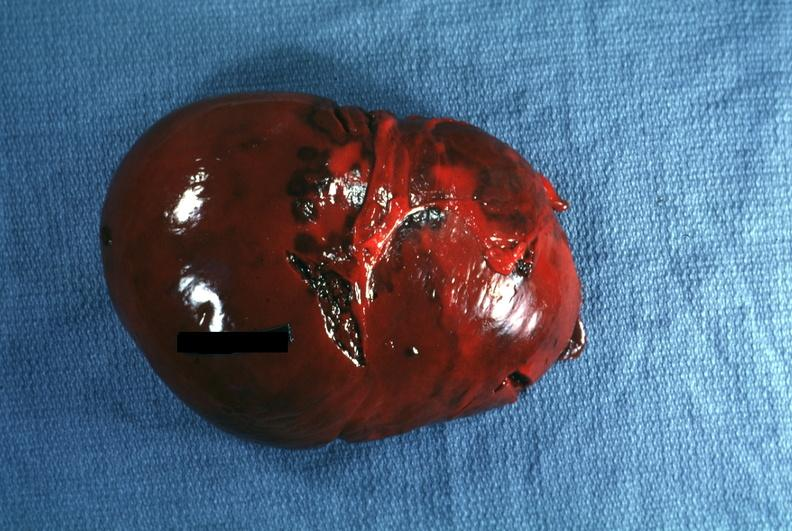s source present?
Answer the question using a single word or phrase. No 